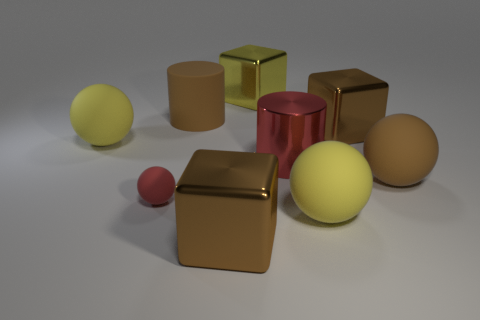Are there any other things that are the same size as the red sphere?
Keep it short and to the point. No. There is another thing that is the same color as the small rubber thing; what size is it?
Offer a very short reply. Large. There is a small matte ball; does it have the same color as the cylinder that is right of the yellow metal thing?
Provide a short and direct response. Yes. Are there fewer large metallic cylinders than tiny purple matte cubes?
Your answer should be compact. No. Does the metal object in front of the small red thing have the same color as the large matte cylinder?
Keep it short and to the point. Yes. What number of matte things are the same size as the brown rubber ball?
Ensure brevity in your answer.  3. Is there a big shiny object of the same color as the small sphere?
Your answer should be compact. Yes. Is the material of the large red thing the same as the red sphere?
Provide a short and direct response. No. How many other big objects have the same shape as the yellow metallic thing?
Offer a very short reply. 2. There is a big yellow object that is made of the same material as the large red object; what is its shape?
Provide a short and direct response. Cube. 